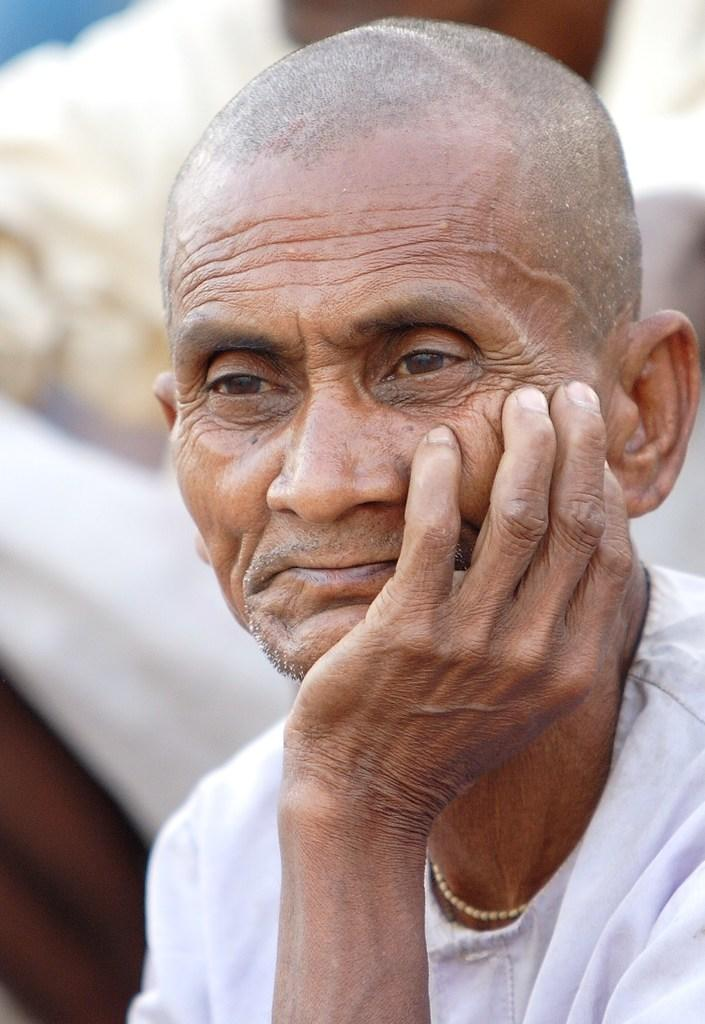Who or what is the main subject of the image? There is a person in the image. What is the person wearing? The person is wearing a white dress. Can you describe the background of the image? The background of the image is blurred. What type of clouds can be seen in the image? There are no clouds visible in the image, as the background is blurred and does not show any specific details. 